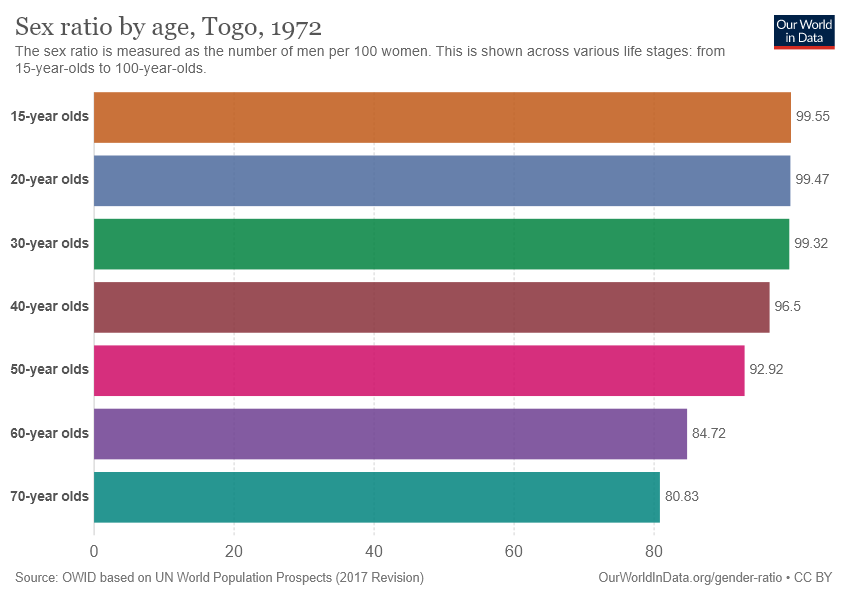Point out several critical features in this image. Of the age ranges examined, those with a sex ratio of over 90 are present in 5 or more individuals. The chart includes a total of 7 age ranges. 